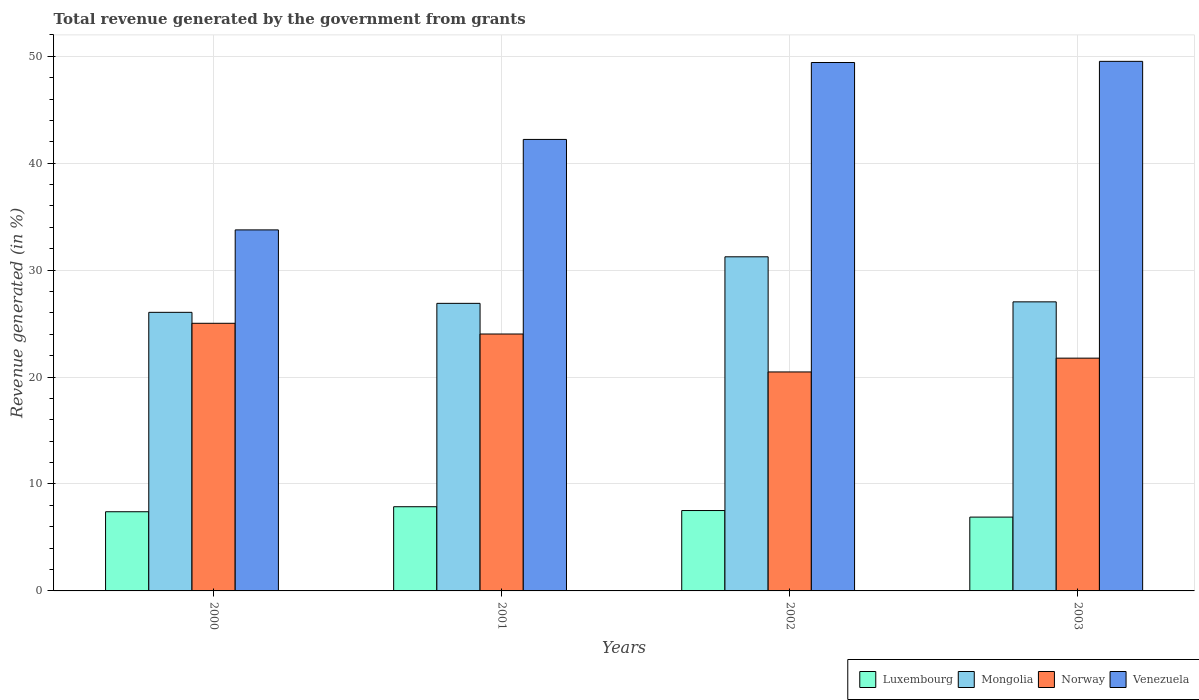How many different coloured bars are there?
Your answer should be compact. 4. How many groups of bars are there?
Offer a terse response. 4. Are the number of bars per tick equal to the number of legend labels?
Make the answer very short. Yes. How many bars are there on the 1st tick from the right?
Your response must be concise. 4. In how many cases, is the number of bars for a given year not equal to the number of legend labels?
Offer a terse response. 0. What is the total revenue generated in Mongolia in 2002?
Your answer should be very brief. 31.25. Across all years, what is the maximum total revenue generated in Luxembourg?
Provide a succinct answer. 7.87. Across all years, what is the minimum total revenue generated in Venezuela?
Provide a short and direct response. 33.76. In which year was the total revenue generated in Mongolia maximum?
Make the answer very short. 2002. In which year was the total revenue generated in Mongolia minimum?
Offer a very short reply. 2000. What is the total total revenue generated in Luxembourg in the graph?
Offer a very short reply. 29.7. What is the difference between the total revenue generated in Mongolia in 2001 and that in 2002?
Ensure brevity in your answer.  -4.35. What is the difference between the total revenue generated in Mongolia in 2000 and the total revenue generated in Norway in 2002?
Keep it short and to the point. 5.58. What is the average total revenue generated in Norway per year?
Provide a short and direct response. 22.83. In the year 2003, what is the difference between the total revenue generated in Mongolia and total revenue generated in Venezuela?
Provide a succinct answer. -22.49. In how many years, is the total revenue generated in Mongolia greater than 42 %?
Keep it short and to the point. 0. What is the ratio of the total revenue generated in Luxembourg in 2001 to that in 2003?
Ensure brevity in your answer.  1.14. Is the total revenue generated in Norway in 2000 less than that in 2001?
Give a very brief answer. No. Is the difference between the total revenue generated in Mongolia in 2002 and 2003 greater than the difference between the total revenue generated in Venezuela in 2002 and 2003?
Provide a succinct answer. Yes. What is the difference between the highest and the second highest total revenue generated in Luxembourg?
Your answer should be compact. 0.36. What is the difference between the highest and the lowest total revenue generated in Mongolia?
Offer a very short reply. 5.19. Is the sum of the total revenue generated in Norway in 2002 and 2003 greater than the maximum total revenue generated in Venezuela across all years?
Offer a terse response. No. What does the 3rd bar from the left in 2002 represents?
Your answer should be compact. Norway. What does the 3rd bar from the right in 2003 represents?
Ensure brevity in your answer.  Mongolia. Is it the case that in every year, the sum of the total revenue generated in Venezuela and total revenue generated in Mongolia is greater than the total revenue generated in Luxembourg?
Your response must be concise. Yes. Are all the bars in the graph horizontal?
Make the answer very short. No. What is the difference between two consecutive major ticks on the Y-axis?
Your answer should be compact. 10. Where does the legend appear in the graph?
Provide a succinct answer. Bottom right. How many legend labels are there?
Your answer should be very brief. 4. How are the legend labels stacked?
Give a very brief answer. Horizontal. What is the title of the graph?
Keep it short and to the point. Total revenue generated by the government from grants. Does "Least developed countries" appear as one of the legend labels in the graph?
Give a very brief answer. No. What is the label or title of the Y-axis?
Make the answer very short. Revenue generated (in %). What is the Revenue generated (in %) in Luxembourg in 2000?
Provide a short and direct response. 7.41. What is the Revenue generated (in %) in Mongolia in 2000?
Make the answer very short. 26.05. What is the Revenue generated (in %) of Norway in 2000?
Provide a short and direct response. 25.03. What is the Revenue generated (in %) of Venezuela in 2000?
Ensure brevity in your answer.  33.76. What is the Revenue generated (in %) of Luxembourg in 2001?
Your response must be concise. 7.87. What is the Revenue generated (in %) in Mongolia in 2001?
Your response must be concise. 26.89. What is the Revenue generated (in %) in Norway in 2001?
Offer a very short reply. 24.03. What is the Revenue generated (in %) of Venezuela in 2001?
Ensure brevity in your answer.  42.23. What is the Revenue generated (in %) of Luxembourg in 2002?
Provide a succinct answer. 7.52. What is the Revenue generated (in %) in Mongolia in 2002?
Provide a succinct answer. 31.25. What is the Revenue generated (in %) in Norway in 2002?
Ensure brevity in your answer.  20.48. What is the Revenue generated (in %) of Venezuela in 2002?
Your answer should be compact. 49.42. What is the Revenue generated (in %) in Luxembourg in 2003?
Offer a terse response. 6.9. What is the Revenue generated (in %) in Mongolia in 2003?
Ensure brevity in your answer.  27.03. What is the Revenue generated (in %) of Norway in 2003?
Your answer should be compact. 21.77. What is the Revenue generated (in %) in Venezuela in 2003?
Make the answer very short. 49.53. Across all years, what is the maximum Revenue generated (in %) in Luxembourg?
Offer a very short reply. 7.87. Across all years, what is the maximum Revenue generated (in %) in Mongolia?
Make the answer very short. 31.25. Across all years, what is the maximum Revenue generated (in %) of Norway?
Give a very brief answer. 25.03. Across all years, what is the maximum Revenue generated (in %) of Venezuela?
Give a very brief answer. 49.53. Across all years, what is the minimum Revenue generated (in %) in Luxembourg?
Provide a short and direct response. 6.9. Across all years, what is the minimum Revenue generated (in %) of Mongolia?
Provide a succinct answer. 26.05. Across all years, what is the minimum Revenue generated (in %) in Norway?
Ensure brevity in your answer.  20.48. Across all years, what is the minimum Revenue generated (in %) of Venezuela?
Your answer should be very brief. 33.76. What is the total Revenue generated (in %) in Luxembourg in the graph?
Ensure brevity in your answer.  29.7. What is the total Revenue generated (in %) in Mongolia in the graph?
Offer a very short reply. 111.23. What is the total Revenue generated (in %) in Norway in the graph?
Ensure brevity in your answer.  91.31. What is the total Revenue generated (in %) of Venezuela in the graph?
Offer a very short reply. 174.94. What is the difference between the Revenue generated (in %) in Luxembourg in 2000 and that in 2001?
Give a very brief answer. -0.47. What is the difference between the Revenue generated (in %) in Mongolia in 2000 and that in 2001?
Provide a succinct answer. -0.84. What is the difference between the Revenue generated (in %) of Norway in 2000 and that in 2001?
Provide a succinct answer. 1. What is the difference between the Revenue generated (in %) of Venezuela in 2000 and that in 2001?
Provide a short and direct response. -8.46. What is the difference between the Revenue generated (in %) in Luxembourg in 2000 and that in 2002?
Give a very brief answer. -0.11. What is the difference between the Revenue generated (in %) of Mongolia in 2000 and that in 2002?
Ensure brevity in your answer.  -5.19. What is the difference between the Revenue generated (in %) of Norway in 2000 and that in 2002?
Make the answer very short. 4.55. What is the difference between the Revenue generated (in %) of Venezuela in 2000 and that in 2002?
Your response must be concise. -15.65. What is the difference between the Revenue generated (in %) of Luxembourg in 2000 and that in 2003?
Offer a terse response. 0.5. What is the difference between the Revenue generated (in %) of Mongolia in 2000 and that in 2003?
Keep it short and to the point. -0.98. What is the difference between the Revenue generated (in %) in Norway in 2000 and that in 2003?
Your response must be concise. 3.26. What is the difference between the Revenue generated (in %) in Venezuela in 2000 and that in 2003?
Your response must be concise. -15.76. What is the difference between the Revenue generated (in %) in Luxembourg in 2001 and that in 2002?
Offer a terse response. 0.36. What is the difference between the Revenue generated (in %) of Mongolia in 2001 and that in 2002?
Offer a terse response. -4.35. What is the difference between the Revenue generated (in %) of Norway in 2001 and that in 2002?
Keep it short and to the point. 3.55. What is the difference between the Revenue generated (in %) in Venezuela in 2001 and that in 2002?
Your answer should be compact. -7.19. What is the difference between the Revenue generated (in %) of Luxembourg in 2001 and that in 2003?
Offer a terse response. 0.97. What is the difference between the Revenue generated (in %) of Mongolia in 2001 and that in 2003?
Your response must be concise. -0.14. What is the difference between the Revenue generated (in %) in Norway in 2001 and that in 2003?
Provide a short and direct response. 2.26. What is the difference between the Revenue generated (in %) in Venezuela in 2001 and that in 2003?
Your response must be concise. -7.3. What is the difference between the Revenue generated (in %) in Luxembourg in 2002 and that in 2003?
Make the answer very short. 0.61. What is the difference between the Revenue generated (in %) in Mongolia in 2002 and that in 2003?
Keep it short and to the point. 4.21. What is the difference between the Revenue generated (in %) of Norway in 2002 and that in 2003?
Offer a very short reply. -1.29. What is the difference between the Revenue generated (in %) of Venezuela in 2002 and that in 2003?
Provide a succinct answer. -0.11. What is the difference between the Revenue generated (in %) in Luxembourg in 2000 and the Revenue generated (in %) in Mongolia in 2001?
Your response must be concise. -19.49. What is the difference between the Revenue generated (in %) in Luxembourg in 2000 and the Revenue generated (in %) in Norway in 2001?
Your answer should be very brief. -16.62. What is the difference between the Revenue generated (in %) of Luxembourg in 2000 and the Revenue generated (in %) of Venezuela in 2001?
Your answer should be very brief. -34.82. What is the difference between the Revenue generated (in %) in Mongolia in 2000 and the Revenue generated (in %) in Norway in 2001?
Offer a terse response. 2.03. What is the difference between the Revenue generated (in %) of Mongolia in 2000 and the Revenue generated (in %) of Venezuela in 2001?
Provide a succinct answer. -16.17. What is the difference between the Revenue generated (in %) of Norway in 2000 and the Revenue generated (in %) of Venezuela in 2001?
Your answer should be compact. -17.2. What is the difference between the Revenue generated (in %) of Luxembourg in 2000 and the Revenue generated (in %) of Mongolia in 2002?
Your answer should be compact. -23.84. What is the difference between the Revenue generated (in %) of Luxembourg in 2000 and the Revenue generated (in %) of Norway in 2002?
Keep it short and to the point. -13.07. What is the difference between the Revenue generated (in %) of Luxembourg in 2000 and the Revenue generated (in %) of Venezuela in 2002?
Your answer should be compact. -42.01. What is the difference between the Revenue generated (in %) of Mongolia in 2000 and the Revenue generated (in %) of Norway in 2002?
Offer a very short reply. 5.58. What is the difference between the Revenue generated (in %) in Mongolia in 2000 and the Revenue generated (in %) in Venezuela in 2002?
Ensure brevity in your answer.  -23.36. What is the difference between the Revenue generated (in %) of Norway in 2000 and the Revenue generated (in %) of Venezuela in 2002?
Your response must be concise. -24.39. What is the difference between the Revenue generated (in %) in Luxembourg in 2000 and the Revenue generated (in %) in Mongolia in 2003?
Provide a short and direct response. -19.63. What is the difference between the Revenue generated (in %) of Luxembourg in 2000 and the Revenue generated (in %) of Norway in 2003?
Provide a short and direct response. -14.37. What is the difference between the Revenue generated (in %) of Luxembourg in 2000 and the Revenue generated (in %) of Venezuela in 2003?
Offer a very short reply. -42.12. What is the difference between the Revenue generated (in %) in Mongolia in 2000 and the Revenue generated (in %) in Norway in 2003?
Make the answer very short. 4.28. What is the difference between the Revenue generated (in %) of Mongolia in 2000 and the Revenue generated (in %) of Venezuela in 2003?
Offer a terse response. -23.47. What is the difference between the Revenue generated (in %) of Norway in 2000 and the Revenue generated (in %) of Venezuela in 2003?
Offer a very short reply. -24.5. What is the difference between the Revenue generated (in %) in Luxembourg in 2001 and the Revenue generated (in %) in Mongolia in 2002?
Offer a very short reply. -23.37. What is the difference between the Revenue generated (in %) of Luxembourg in 2001 and the Revenue generated (in %) of Norway in 2002?
Offer a terse response. -12.6. What is the difference between the Revenue generated (in %) of Luxembourg in 2001 and the Revenue generated (in %) of Venezuela in 2002?
Ensure brevity in your answer.  -41.55. What is the difference between the Revenue generated (in %) of Mongolia in 2001 and the Revenue generated (in %) of Norway in 2002?
Provide a short and direct response. 6.42. What is the difference between the Revenue generated (in %) of Mongolia in 2001 and the Revenue generated (in %) of Venezuela in 2002?
Give a very brief answer. -22.52. What is the difference between the Revenue generated (in %) of Norway in 2001 and the Revenue generated (in %) of Venezuela in 2002?
Make the answer very short. -25.39. What is the difference between the Revenue generated (in %) in Luxembourg in 2001 and the Revenue generated (in %) in Mongolia in 2003?
Give a very brief answer. -19.16. What is the difference between the Revenue generated (in %) in Luxembourg in 2001 and the Revenue generated (in %) in Norway in 2003?
Offer a terse response. -13.9. What is the difference between the Revenue generated (in %) in Luxembourg in 2001 and the Revenue generated (in %) in Venezuela in 2003?
Your response must be concise. -41.65. What is the difference between the Revenue generated (in %) in Mongolia in 2001 and the Revenue generated (in %) in Norway in 2003?
Keep it short and to the point. 5.12. What is the difference between the Revenue generated (in %) in Mongolia in 2001 and the Revenue generated (in %) in Venezuela in 2003?
Provide a succinct answer. -22.63. What is the difference between the Revenue generated (in %) in Norway in 2001 and the Revenue generated (in %) in Venezuela in 2003?
Make the answer very short. -25.5. What is the difference between the Revenue generated (in %) in Luxembourg in 2002 and the Revenue generated (in %) in Mongolia in 2003?
Your response must be concise. -19.52. What is the difference between the Revenue generated (in %) of Luxembourg in 2002 and the Revenue generated (in %) of Norway in 2003?
Offer a terse response. -14.25. What is the difference between the Revenue generated (in %) of Luxembourg in 2002 and the Revenue generated (in %) of Venezuela in 2003?
Keep it short and to the point. -42.01. What is the difference between the Revenue generated (in %) in Mongolia in 2002 and the Revenue generated (in %) in Norway in 2003?
Ensure brevity in your answer.  9.48. What is the difference between the Revenue generated (in %) of Mongolia in 2002 and the Revenue generated (in %) of Venezuela in 2003?
Offer a terse response. -18.28. What is the difference between the Revenue generated (in %) of Norway in 2002 and the Revenue generated (in %) of Venezuela in 2003?
Offer a terse response. -29.05. What is the average Revenue generated (in %) in Luxembourg per year?
Give a very brief answer. 7.43. What is the average Revenue generated (in %) of Mongolia per year?
Offer a terse response. 27.81. What is the average Revenue generated (in %) in Norway per year?
Your answer should be very brief. 22.83. What is the average Revenue generated (in %) of Venezuela per year?
Your answer should be very brief. 43.73. In the year 2000, what is the difference between the Revenue generated (in %) in Luxembourg and Revenue generated (in %) in Mongolia?
Make the answer very short. -18.65. In the year 2000, what is the difference between the Revenue generated (in %) in Luxembourg and Revenue generated (in %) in Norway?
Ensure brevity in your answer.  -17.62. In the year 2000, what is the difference between the Revenue generated (in %) in Luxembourg and Revenue generated (in %) in Venezuela?
Your answer should be compact. -26.36. In the year 2000, what is the difference between the Revenue generated (in %) in Mongolia and Revenue generated (in %) in Norway?
Offer a terse response. 1.03. In the year 2000, what is the difference between the Revenue generated (in %) in Mongolia and Revenue generated (in %) in Venezuela?
Your response must be concise. -7.71. In the year 2000, what is the difference between the Revenue generated (in %) of Norway and Revenue generated (in %) of Venezuela?
Your answer should be compact. -8.73. In the year 2001, what is the difference between the Revenue generated (in %) of Luxembourg and Revenue generated (in %) of Mongolia?
Your answer should be compact. -19.02. In the year 2001, what is the difference between the Revenue generated (in %) of Luxembourg and Revenue generated (in %) of Norway?
Your response must be concise. -16.15. In the year 2001, what is the difference between the Revenue generated (in %) of Luxembourg and Revenue generated (in %) of Venezuela?
Offer a terse response. -34.35. In the year 2001, what is the difference between the Revenue generated (in %) of Mongolia and Revenue generated (in %) of Norway?
Your response must be concise. 2.87. In the year 2001, what is the difference between the Revenue generated (in %) in Mongolia and Revenue generated (in %) in Venezuela?
Keep it short and to the point. -15.33. In the year 2001, what is the difference between the Revenue generated (in %) in Norway and Revenue generated (in %) in Venezuela?
Give a very brief answer. -18.2. In the year 2002, what is the difference between the Revenue generated (in %) of Luxembourg and Revenue generated (in %) of Mongolia?
Make the answer very short. -23.73. In the year 2002, what is the difference between the Revenue generated (in %) of Luxembourg and Revenue generated (in %) of Norway?
Offer a terse response. -12.96. In the year 2002, what is the difference between the Revenue generated (in %) in Luxembourg and Revenue generated (in %) in Venezuela?
Give a very brief answer. -41.9. In the year 2002, what is the difference between the Revenue generated (in %) of Mongolia and Revenue generated (in %) of Norway?
Provide a short and direct response. 10.77. In the year 2002, what is the difference between the Revenue generated (in %) in Mongolia and Revenue generated (in %) in Venezuela?
Offer a terse response. -18.17. In the year 2002, what is the difference between the Revenue generated (in %) of Norway and Revenue generated (in %) of Venezuela?
Provide a succinct answer. -28.94. In the year 2003, what is the difference between the Revenue generated (in %) of Luxembourg and Revenue generated (in %) of Mongolia?
Provide a succinct answer. -20.13. In the year 2003, what is the difference between the Revenue generated (in %) of Luxembourg and Revenue generated (in %) of Norway?
Provide a succinct answer. -14.87. In the year 2003, what is the difference between the Revenue generated (in %) in Luxembourg and Revenue generated (in %) in Venezuela?
Offer a terse response. -42.62. In the year 2003, what is the difference between the Revenue generated (in %) of Mongolia and Revenue generated (in %) of Norway?
Offer a terse response. 5.26. In the year 2003, what is the difference between the Revenue generated (in %) of Mongolia and Revenue generated (in %) of Venezuela?
Offer a very short reply. -22.49. In the year 2003, what is the difference between the Revenue generated (in %) in Norway and Revenue generated (in %) in Venezuela?
Ensure brevity in your answer.  -27.76. What is the ratio of the Revenue generated (in %) of Luxembourg in 2000 to that in 2001?
Keep it short and to the point. 0.94. What is the ratio of the Revenue generated (in %) in Mongolia in 2000 to that in 2001?
Provide a short and direct response. 0.97. What is the ratio of the Revenue generated (in %) in Norway in 2000 to that in 2001?
Provide a short and direct response. 1.04. What is the ratio of the Revenue generated (in %) in Venezuela in 2000 to that in 2001?
Ensure brevity in your answer.  0.8. What is the ratio of the Revenue generated (in %) in Luxembourg in 2000 to that in 2002?
Offer a terse response. 0.98. What is the ratio of the Revenue generated (in %) in Mongolia in 2000 to that in 2002?
Provide a succinct answer. 0.83. What is the ratio of the Revenue generated (in %) in Norway in 2000 to that in 2002?
Provide a short and direct response. 1.22. What is the ratio of the Revenue generated (in %) of Venezuela in 2000 to that in 2002?
Offer a very short reply. 0.68. What is the ratio of the Revenue generated (in %) of Luxembourg in 2000 to that in 2003?
Your response must be concise. 1.07. What is the ratio of the Revenue generated (in %) in Mongolia in 2000 to that in 2003?
Your answer should be compact. 0.96. What is the ratio of the Revenue generated (in %) in Norway in 2000 to that in 2003?
Provide a succinct answer. 1.15. What is the ratio of the Revenue generated (in %) in Venezuela in 2000 to that in 2003?
Ensure brevity in your answer.  0.68. What is the ratio of the Revenue generated (in %) in Luxembourg in 2001 to that in 2002?
Give a very brief answer. 1.05. What is the ratio of the Revenue generated (in %) in Mongolia in 2001 to that in 2002?
Your response must be concise. 0.86. What is the ratio of the Revenue generated (in %) in Norway in 2001 to that in 2002?
Provide a short and direct response. 1.17. What is the ratio of the Revenue generated (in %) of Venezuela in 2001 to that in 2002?
Ensure brevity in your answer.  0.85. What is the ratio of the Revenue generated (in %) of Luxembourg in 2001 to that in 2003?
Keep it short and to the point. 1.14. What is the ratio of the Revenue generated (in %) in Norway in 2001 to that in 2003?
Your answer should be compact. 1.1. What is the ratio of the Revenue generated (in %) in Venezuela in 2001 to that in 2003?
Make the answer very short. 0.85. What is the ratio of the Revenue generated (in %) in Luxembourg in 2002 to that in 2003?
Keep it short and to the point. 1.09. What is the ratio of the Revenue generated (in %) of Mongolia in 2002 to that in 2003?
Your response must be concise. 1.16. What is the ratio of the Revenue generated (in %) in Norway in 2002 to that in 2003?
Make the answer very short. 0.94. What is the difference between the highest and the second highest Revenue generated (in %) of Luxembourg?
Provide a succinct answer. 0.36. What is the difference between the highest and the second highest Revenue generated (in %) of Mongolia?
Your answer should be compact. 4.21. What is the difference between the highest and the second highest Revenue generated (in %) in Venezuela?
Your response must be concise. 0.11. What is the difference between the highest and the lowest Revenue generated (in %) of Luxembourg?
Provide a succinct answer. 0.97. What is the difference between the highest and the lowest Revenue generated (in %) of Mongolia?
Keep it short and to the point. 5.19. What is the difference between the highest and the lowest Revenue generated (in %) of Norway?
Keep it short and to the point. 4.55. What is the difference between the highest and the lowest Revenue generated (in %) in Venezuela?
Offer a very short reply. 15.76. 